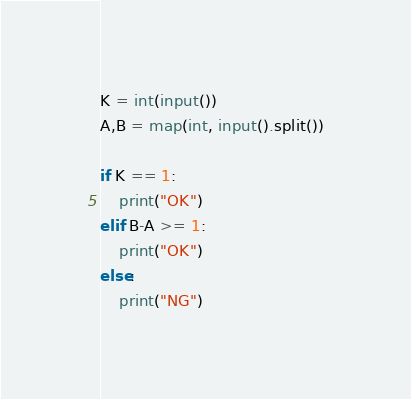<code> <loc_0><loc_0><loc_500><loc_500><_Python_>K = int(input())
A,B = map(int, input().split())

if K == 1:
    print("OK")
elif B-A >= 1:
    print("OK")
else:
    print("NG")</code> 